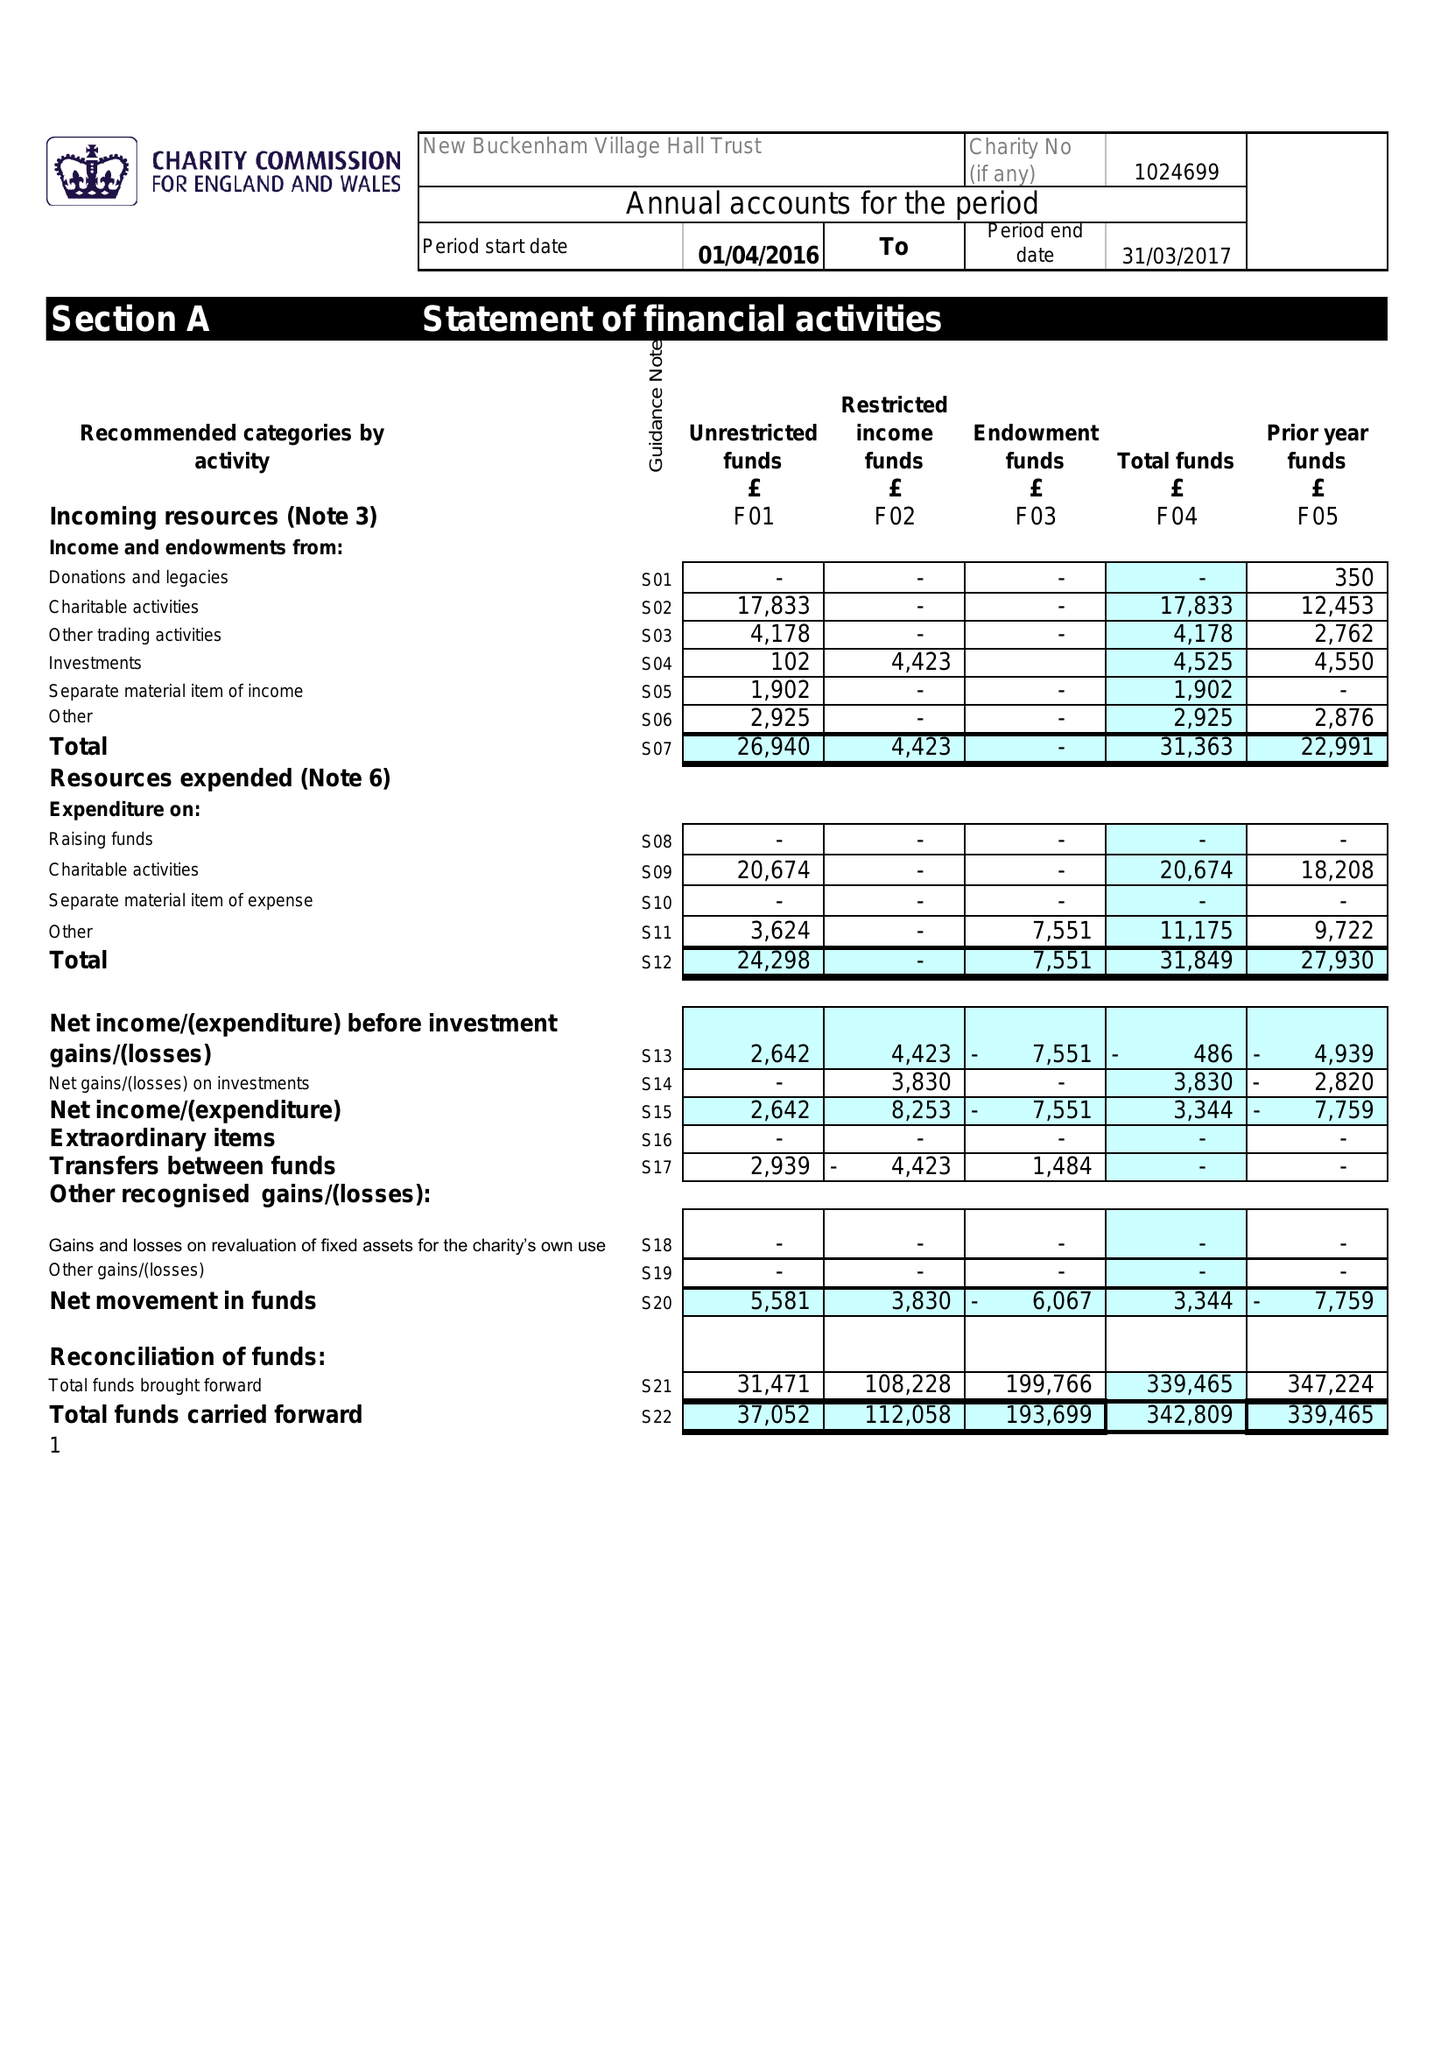What is the value for the report_date?
Answer the question using a single word or phrase. 2017-03-31 